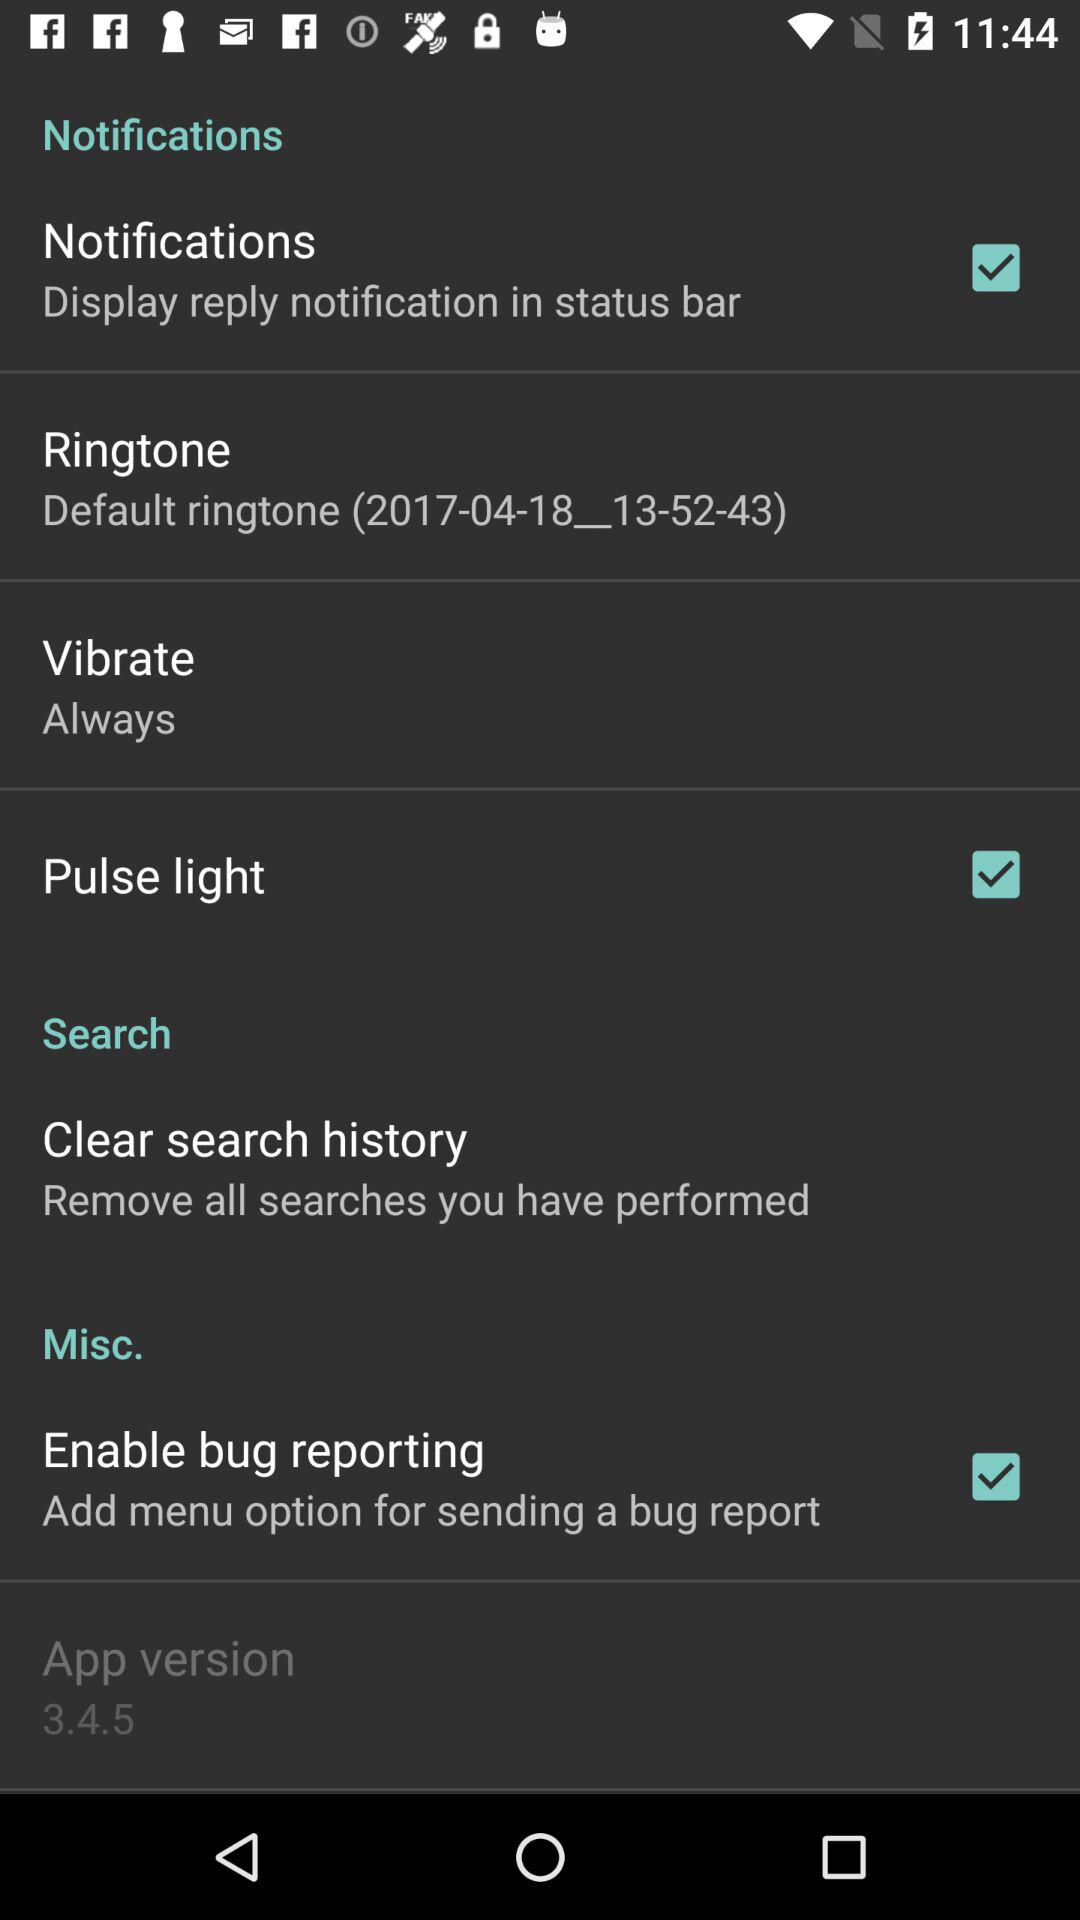What are the selected options? The selected options are "Notifications", "Pulse light" and "Enable bug reporting". 